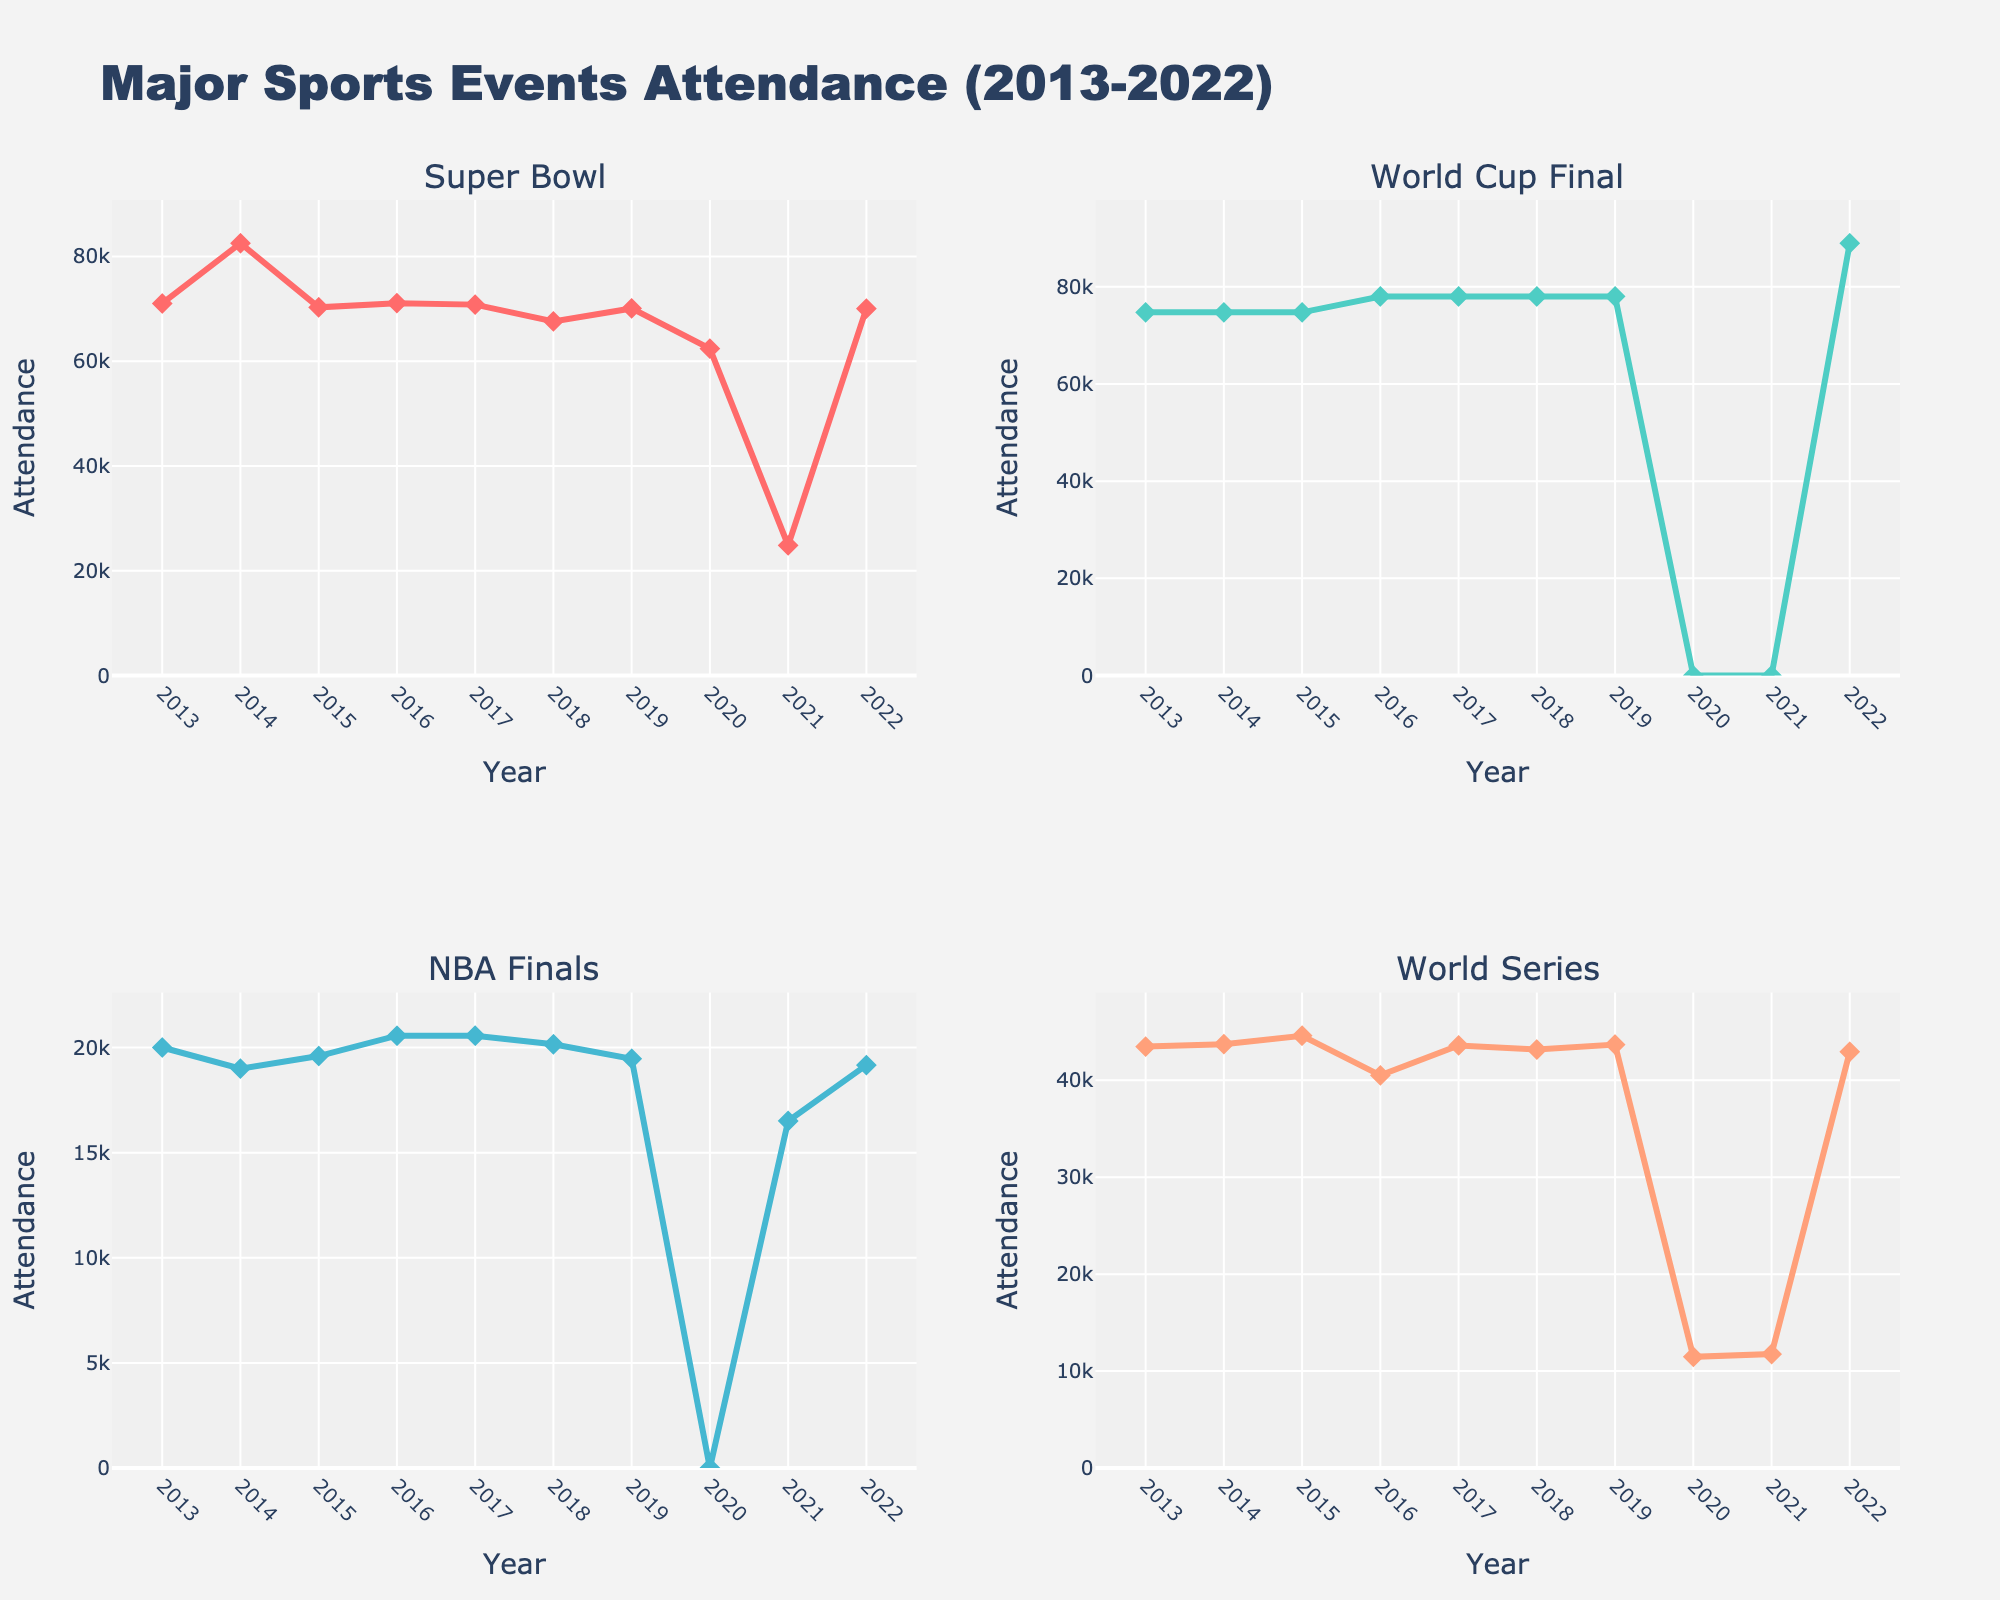What's the title of the figure? The title is displayed prominently at the top of the figure and provides a summary of what the visual represents. It reads "Monthly Follower Growth by Platform".
Answer: Monthly Follower Growth by Platform Which platform shows the highest monthly growth in followers in June? Look at the data points for June across all platforms. TikTok (WRC) reaches the highest value with 10.2% growth.
Answer: TikTok How many months are displayed on the x-axis for each subplot? Each subplot has its horizontal axis showing month labels. By counting these labels, we see six months (Jan to Jun).
Answer: 6 Which Instagram account experienced the highest growth in May? Focus on the May data point for each Instagram account line. The highest is F1 with 4.2%.
Answer: F1 What's the growth trend for the NHRA account on YouTube? Follow the line representing NHRA in the YouTube subplot. It starts at 0.8% in January and increases gradually each month ending at 1.8% in June.
Answer: Increasing trend What is the average follower growth for the MotoGP account on Instagram from January to June? Add the monthly growth percentages for MotoGP from January to June and divide by the number of months (6), i.e., (1.8 + 2.2 + 2.5 + 2.7 + 3.0 + 2.8) / 6.
Answer: 2.5% Which platform shows the most rapid increase in engagement? Compare the slopes of the lines in each subplot. TikTok generally has steeper slopes, signifying faster growth than Instagram and YouTube.
Answer: TikTok What was the follower growth percentage for the Formula E account on TikTok in April? Refer to the specific data point for Formula E in the TikTok subplot for April, found to be 6.1%.
Answer: 6.1% Compare the growth rates between NASCAR (Instagram) and IndyCar (YouTube) in March. Which is higher? Look at the March data points for both accounts. NASCAR has 1.7% and IndyCar has 2.0%. 2.0% is higher.
Answer: IndyCar Which account on YouTube had the lowest follower growth in January? In the YouTube subplot, compare January data points. FIA WEC has the lowest with 0.6%.
Answer: FIA WEC 